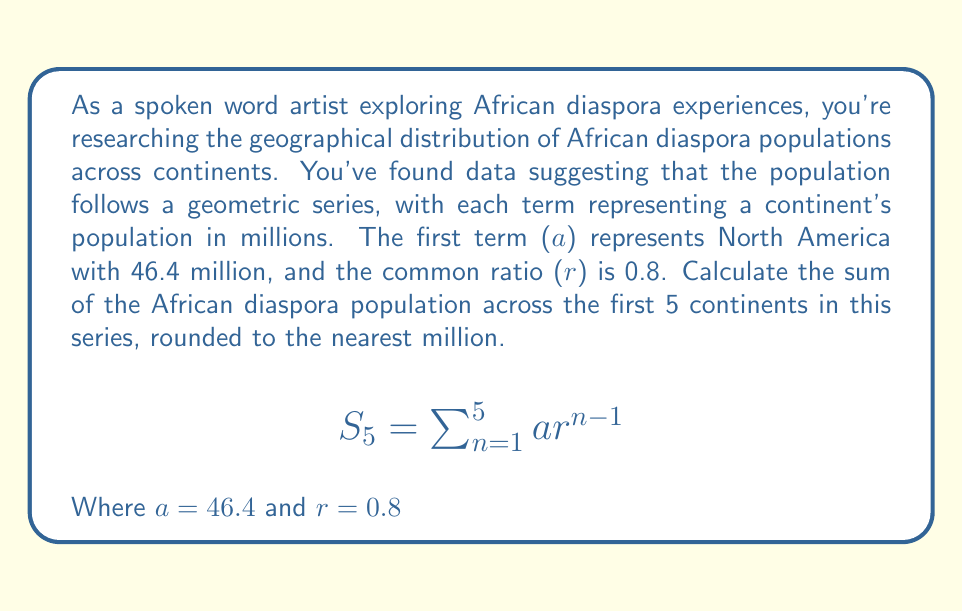Show me your answer to this math problem. To solve this problem, we'll use the formula for the sum of a geometric series:

$$S_n = \frac{a(1-r^n)}{1-r}$$

Where:
$S_n$ is the sum of the first n terms
$a$ is the first term
$r$ is the common ratio
$n$ is the number of terms

Given:
$a = 46.4$ million
$r = 0.8$
$n = 5$ continents

Let's substitute these values into the formula:

$$S_5 = \frac{46.4(1-0.8^5)}{1-0.8}$$

Now, let's calculate step by step:

1. Calculate $0.8^5$:
   $0.8^5 = 0.32768$

2. Subtract this from 1:
   $1 - 0.8^5 = 1 - 0.32768 = 0.67232$

3. Multiply by the first term:
   $46.4 \times 0.67232 = 31.195648$

4. Calculate $1 - r$:
   $1 - 0.8 = 0.2$

5. Divide the result from step 3 by the result from step 4:
   $\frac{31.195648}{0.2} = 155.97824$

6. Round to the nearest million:
   $155.97824 \approx 156$ million
Answer: The sum of the African diaspora population across the first 5 continents in this geometric series is approximately 156 million. 